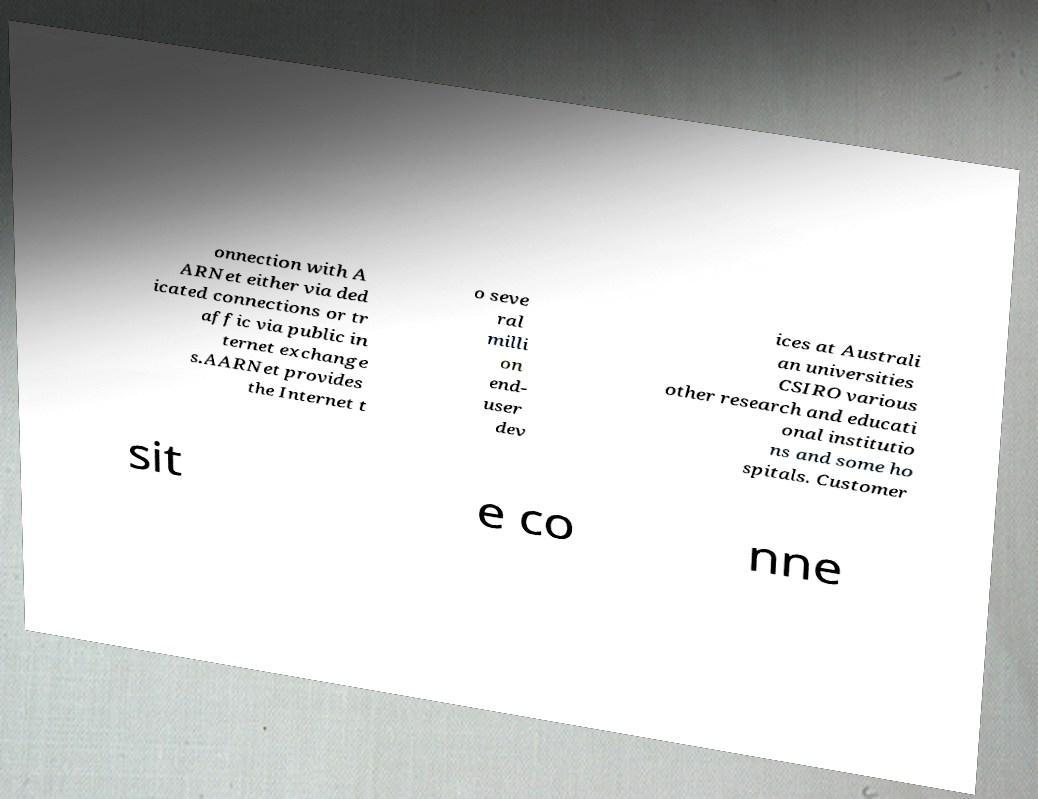Can you read and provide the text displayed in the image?This photo seems to have some interesting text. Can you extract and type it out for me? onnection with A ARNet either via ded icated connections or tr affic via public in ternet exchange s.AARNet provides the Internet t o seve ral milli on end- user dev ices at Australi an universities CSIRO various other research and educati onal institutio ns and some ho spitals. Customer sit e co nne 